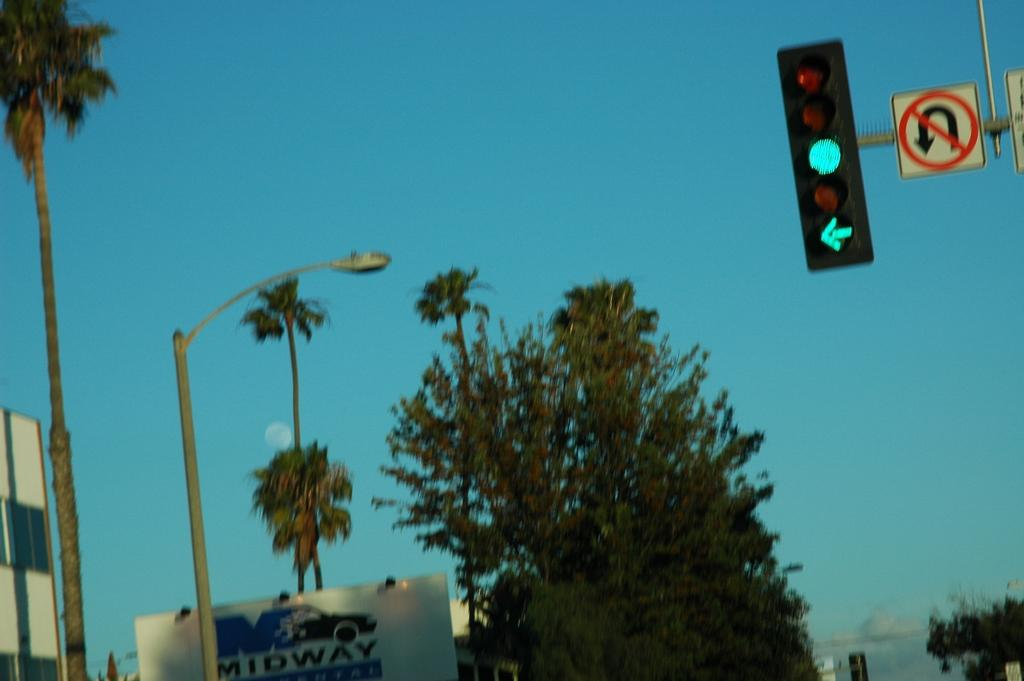<image>
Share a concise interpretation of the image provided. A green stoplight arrow is pointing towards a Midway sign 